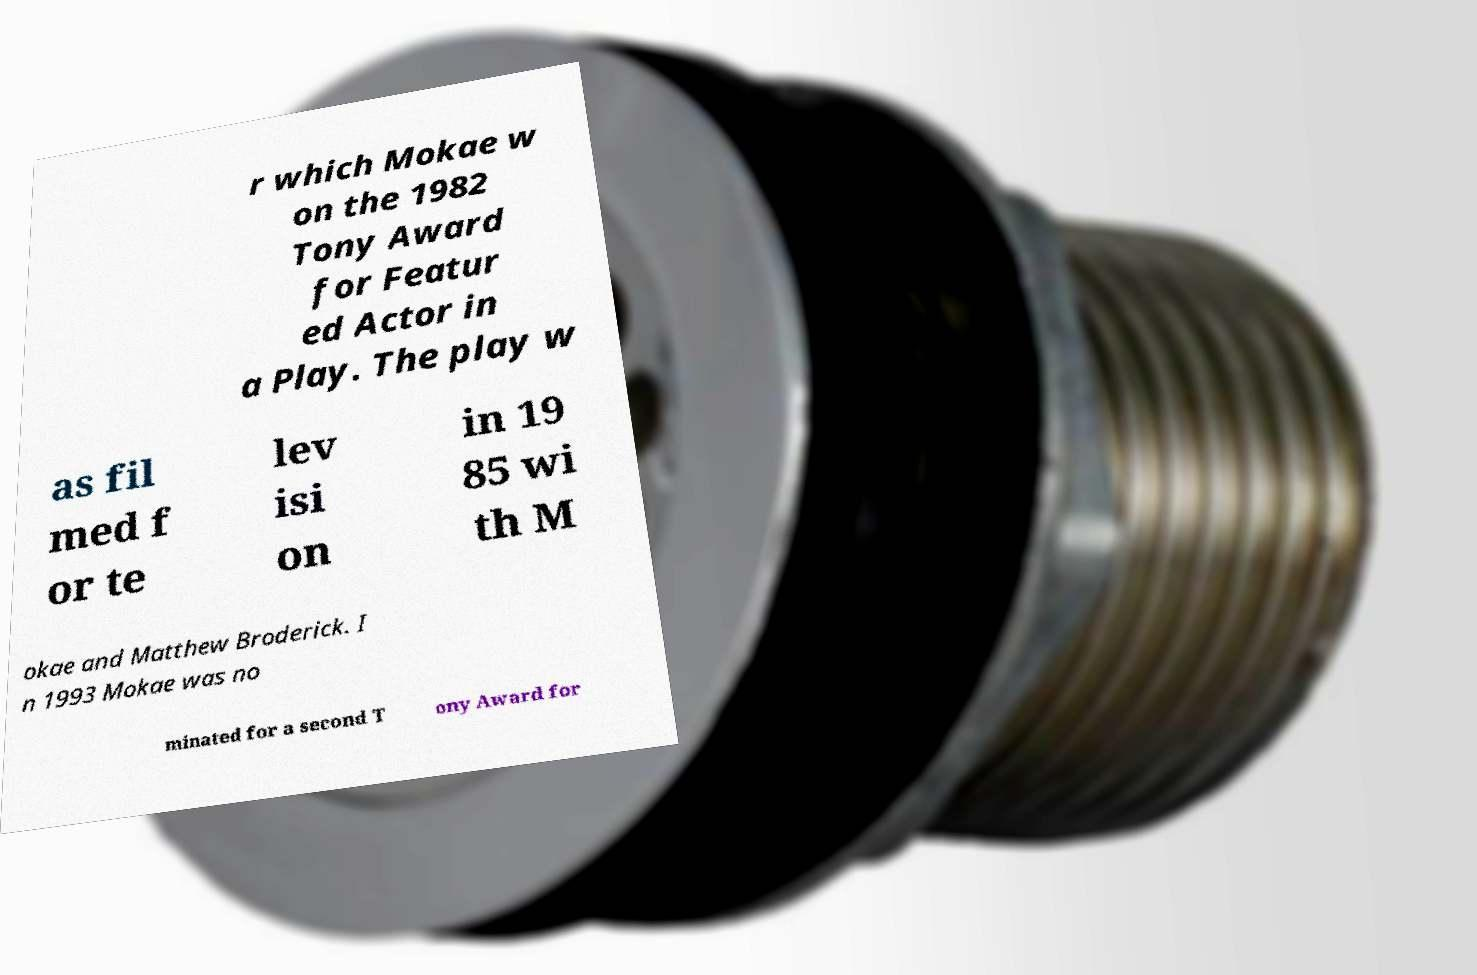What messages or text are displayed in this image? I need them in a readable, typed format. r which Mokae w on the 1982 Tony Award for Featur ed Actor in a Play. The play w as fil med f or te lev isi on in 19 85 wi th M okae and Matthew Broderick. I n 1993 Mokae was no minated for a second T ony Award for 